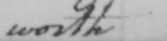What is written in this line of handwriting? worth 